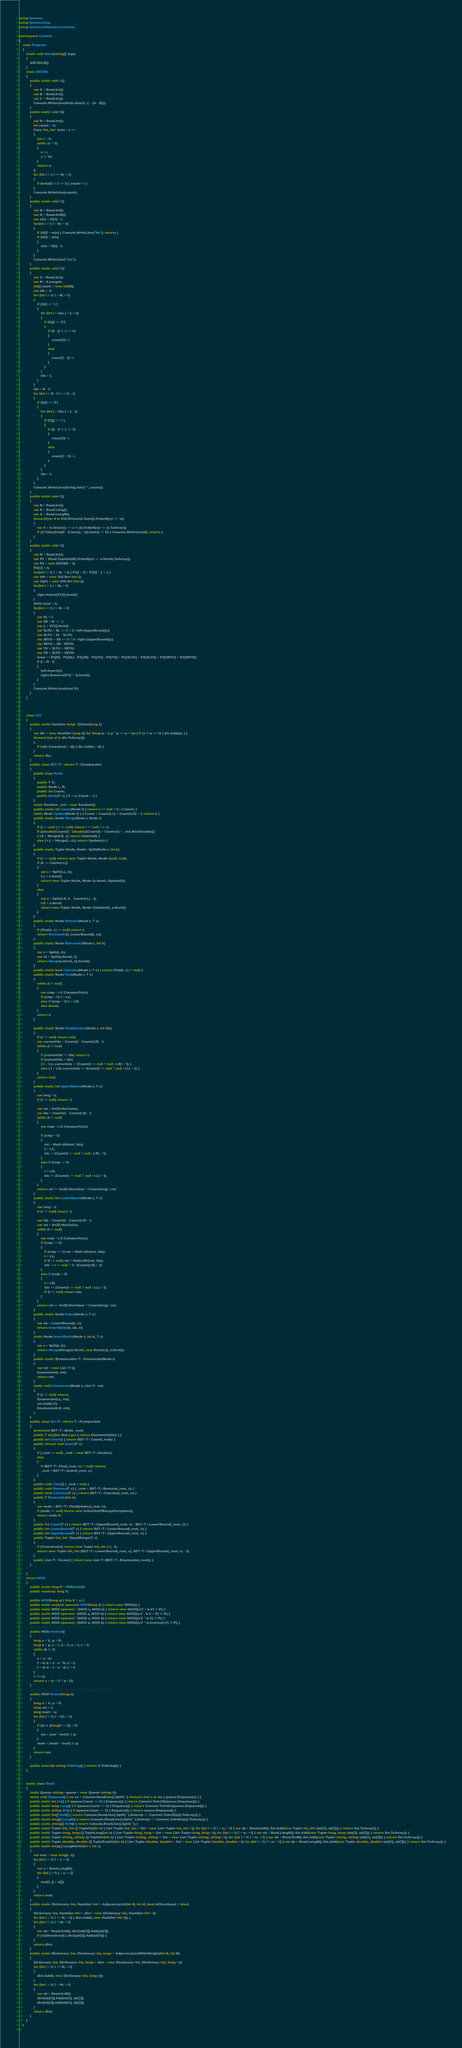<code> <loc_0><loc_0><loc_500><loc_500><_C#_>using System;
using System.Linq;
using System.Collections.Generic;

namespace Contest
{
    class Program
    {
        static void Main(string[] args)
        {
            ABC136.B();
        }
        class ABC136
        {
            public static void A()
            {
                var A = Read.Int();
                var B = Read.Int();
                var C = Read.Int();
                Console.WriteLine(Math.Max(0, C - (A - B)));
            }
            public static void B()
            {
                var N = Read.Int();
                int count = 0;
                Func<int, int> keta = x =>
                {
                    int c = 0;
                    while (x > 0)
                    {
                        c++;
                        x /= 10;
                    }
                    return c;
                };
                for (int i = 1; i <= N; ++i)
                {
                    if (keta(i) % 2 == 1) { count++; }
                }
                Console.WriteLine(count);
            }
            public static void C()
            {
                var N = Read.Int();
                var H = Read.IntN();
                var min = H[0] - 1;
                for(int i = 1; i < N; ++i)
                {
                    if (H[i] < min) { Console.WriteLine("No"); return; }
                    if (H[i] > min)
                    {
                        min = H[i] - 1;
                    }
                }
                Console.WriteLine("Yes");
            }
            public static void D()
            {
                var S = Read.Str();
                var N = S.Length;
                int[] count = new int[N];
                var idx = 0;
                for (int i = 0; i < N; ++i)
                {
                    if (S[i] == 'L')
                    {
                        for (int j = idx; j < i; ++j)
                        {
                            if (S[j] == 'R')
                            {
                                if ((i - j) % 2 == 0)
                                {
                                    count[i]++;
                                }
                                else
                                {
                                    count[i - 1]++;
                                }
                            }
                        }
                        idx = i;
                    }
                }
                idx = N - 1;
                for (int i = N - 1; i >= 0; --i)
                {
                    if (S[i] == 'R')
                    {
                        for (int j = idx; j > i; --j)
                        {
                            if (S[j] == 'L')
                            {
                                if ((j - i) % 2 == 0)
                                {
                                    count[i]++;
                                }
                                else
                                {
                                    count[i + 1]++;
                                }
                            }
                        }
                        idx = i;
                    }
                }
                Console.WriteLine(String.Join(" ", count));
            }
            public static void E()
            {
                var N = Read.Int();
                var K = Read.Long();
                var A = Read.LongN();
                foreach(var d in Util.Divisor(A.Sum()).OrderBy(x => -x))
                {
                    var X = A.Select(x => x % d).OrderBy(x => x).ToArray();
                    if (X.Take((int)(N - X.Sum() / d)).Sum() <= K) { Console.WriteLine(d); return; }
                }
            }
            public static void F()
            {
                var N = Read.Int();
                var XY = Read.TupleInt(N).OrderBy(x => x.Item1).ToArray();
                var P2 = new MOD[N + 1];
                P2[0] = 0;
                for(int i = 0; i < N; ++i) { P2[i + 1] = P2[i] * 2 + 1; }
                var left = new Util.Set<int>();
                var right = new Util.Set<int>();
                for(int i = 1; i < N; ++i)
                {
                    right.Insert(XY[i].Item2);
                }
                MOD total = 0;
                for(int i = 0; i < N; ++i)
                {
                    var XL = i;
                    var XR = N - i - 1;
                    var y = XY[i].Item2;
                    var XLYD = XL == 0 ? 0 : left.UpperBound(y);
                    var XLYU = XL - XLYD;
                    var XRYD = XR == 0 ? 0 : right.UpperBound(y);
                    var XRYU = XR - XRYD;
                    var YU = XLYU + XRYU;
                    var YD = XLYD + XRYD;
                    total += P2[N] - P2[XL] - P2[XR] - P2[YU] - P2[YD] + P2[XLYU] + P2[XLYD] + P2[XRYU] + P2[XRYD];
                    if (i < N - 1)
                    {
                        left.Insert(y);
                        right.Remove(XY[i + 1].Item2);
                    }
                }
                Console.WriteLine(total.V);
            }
        }



        class Util
        {
            public static HashSet<long> Divisor(long x)
            {
                var div = new HashSet<long>(); for (long p = 1; p * p <= x; ++p) { if (x % p == 0) { div.Add(p); } }
                foreach (var d in div.ToArray())
                {
                    if (!div.Contains(x / d)) { div.Add(x / d); }
                }
                return div;
            }
            public class BST<T> where T : IComparable
            {
                public class Node
                {
                    public T V;
                    public Node L, R;
                    public int Count;
                    public Node(T v) { V = v; Count = 1; }
                }
                static Random _rnd = new Random();
                public static int Count(Node t) { return t == null ? 0 : t.Count; }
                static Node Update(Node t) { t.Count = Count(t.L) + Count(t.R) + 1; return t; }
                public static Node Merge(Node l, Node r)
                {
                    if (l == null || r == null) return l == null ? r : l;
                    if ((double)Count(l) / (double)(Count(l) + Count(r)) > _rnd.NextDouble())
                    { l.R = Merge(l.R, r); return Update(l); }
                    else { r.L = Merge(l, r.L); return Update(r); }
                }
                public static Tuple<Node, Node> Split(Node t, int k)
                {
                    if (t == null) return new Tuple<Node, Node>(null, null);
                    if (k <= Count(t.L))
                    {
                        var s = Split(t.L, k);
                        t.L = s.Item2;
                        return new Tuple<Node, Node>(s.Item1, Update(t));
                    }
                    else
                    {
                        var s = Split(t.R, k - Count(t.L) - 1);
                        t.R = s.Item1;
                        return new Tuple<Node, Node>(Update(t), s.Item2);
                    }
                }
                public static Node Remove(Node t, T v)
                {
                    if (Find(t, v) == null) return t;
                    return RemoveAt(t, LowerBound(t, v));
                }
                public static Node RemoveAt(Node t, int k)
                {
                    var s = Split(t, k);
                    var s2 = Split(s.Item2, 1);
                    return Merge(s.Item1, s2.Item2);
                }
                public static bool Contains(Node t, T v) { return Find(t, v) != null; }
                public static Node Find(Node t, T v)
                {
                    while (t != null)
                    {
                        var cmp = t.V.CompareTo(v);
                        if (cmp > 0) t = t.L;
                        else if (cmp < 0) t = t.R;
                        else break;
                    }
                    return t;
                }

                public static Node FindByIndex(Node t, int idx)
                {
                    if (t == null) return null;
                    var currentIdx = Count(t) - Count(t.R) - 1;
                    while (t != null)
                    {
                        if (currentIdx == idx) return t;
                        if (currentIdx > idx)
                        { t = t.L; currentIdx -= (Count(t == null ? null : t.R) + 1); }
                        else { t = t.R; currentIdx += (Count(t == null ? null : t.L) + 1); }
                    }
                    return null;
                }
                public static int UpperBound(Node t, T v)
                {
                    var torg = t;
                    if (t == null) return -1;

                    var ret = Int32.MaxValue;
                    var idx = Count(t) - Count(t.R) - 1;
                    while (t != null)
                    {
                        var cmp = t.V.CompareTo(v);

                        if (cmp > 0)
                        {
                            ret = Math.Min(ret, idx);
                            t = t.L;
                            idx -= (Count(t == null ? null : t.R) + 1);
                        }
                        else if (cmp <= 0)
                        {
                            t = t.R;
                            idx += (Count(t == null ? null : t.L) + 1);
                        }
                    }
                    return ret == Int32.MaxValue ? Count(torg) : ret;
                }
                public static int LowerBound(Node t, T v)
                {
                    var torg = t;
                    if (t == null) return -1;

                    var idx = Count(t) - Count(t.R) - 1;
                    var ret = Int32.MaxValue;
                    while (t != null)
                    {
                        var cmp = t.V.CompareTo(v);
                        if (cmp >= 0)
                        {
                            if (cmp == 0) ret = Math.Min(ret, idx);
                            t = t.L;
                            if (t == null) ret = Math.Min(ret, idx);
                            idx -= t == null ? 0 : (Count(t.R) + 1);
                        }
                        else if (cmp < 0)
                        {
                            t = t.R;
                            idx += (Count(t == null ? null : t.L) + 1);
                            if (t == null) return idx;
                        }
                    }
                    return ret == Int32.MaxValue ? Count(torg) : ret;
                }
                public static Node Insert(Node t, T v)
                {
                    var ub = LowerBound(t, v);
                    return InsertByIdx(t, ub, v);
                }
                static Node InsertByIdx(Node t, int k, T v)
                {
                    var s = Split(t, k);
                    return Merge(Merge(s.Item1, new Node(v)), s.Item2);
                }
                public static IEnumerable<T> Enumerate(Node t)
                {
                    var ret = new List<T>();
                    Enumerate(t, ret);
                    return ret;
                }
                static void Enumerate(Node t, List<T> ret)
                {
                    if (t == null) return;
                    Enumerate(t.L, ret);
                    ret.Add(t.V);
                    Enumerate(t.R, ret);
                }
            }
            public class Set<T> where T : IComparable
            {
                protected BST<T>.Node _root;
                public T this[int idx] { get { return ElementAt(idx); } }
                public int Count() { return BST<T>.Count(_root); }
                public virtual void Insert(T v)
                {
                    if (_root == null) _root = new BST<T>.Node(v);
                    else
                    {
                        if (BST<T>.Find(_root, v) != null) return;
                        _root = BST<T>.Insert(_root, v);
                    }
                }
                public void Clear() { _root = null; }
                public void Remove(T v) { _root = BST<T>.Remove(_root, v); }
                public bool Contains(T v) { return BST<T>.Contains(_root, v); }
                public T ElementAt(int k)
                {
                    var node = BST<T>.FindByIndex(_root, k);
                    if (node == null) throw new IndexOutOfRangeException();
                    return node.V;
                }
                public int Count(T v) { return BST<T>.UpperBound(_root, v) - BST<T>.LowerBound(_root, v); }
                public int LowerBound(T v) { return BST<T>.LowerBound(_root, v); }
                public int UpperBound(T v) { return BST<T>.UpperBound(_root, v); }
                public Tuple<int, int> EqualRange(T v)
                {
                    if (!Contains(v)) return new Tuple<int, int>(-1, -1);
                    return new Tuple<int, int>(BST<T>.LowerBound(_root, v), BST<T>.UpperBound(_root, v) - 1);
                }
                public List<T> ToList() { return new List<T>(BST<T>.Enumerate(_root)); }
            }

        }
        struct MOD
        {
            public static long P = 998244353;
            public readonly long V;

            public MOD(long a) { this.V = a; }
            public static implicit operator MOD(long a) { return new MOD(a); }
            public static MOD operator +(MOD a, MOD b) { return new MOD((a.V + b.V) % P); }
            public static MOD operator -(MOD a, MOD b) { return new MOD((a.V - b.V + P) % P); }
            public static MOD operator *(MOD a, MOD b) { return new MOD((a.V * b.V) % P); }
            public static MOD operator /(MOD a, MOD b) { return new MOD((a.V * b.Inverse().V) % P); }
            //public MOD Inverse() { return Util.Inverse(V, P); }
            public MOD Inverse()
            {
                long a = V, p = P;
                long b = p, c = 1, d = 0, e = 0, f = 0;
                while (b != 0)
                {
                    e = a / b;
                    f = b; b = a - e * b; a = f;
                    f = d; d = c - e * d; c = f;
                }
                c %= p;
                return c + (c < 0 ? p : 0);
            }
            //public MOD Power(long n) { return Util.Power(V, n, P); }
            public MOD Power(long n)
            {
                long a = V, p = P;
                long res = 1;
                long mult = a;
                for (int i = 0; i < 40; ++i)
                {
                    if ((n & ((long)1 << i)) > 0)
                    {
                        res = (res * mult) % p;
                    }
                    mult = (mult * mult) % p;
                }
                return res;
            }

            public override string ToString() { return V.ToString(); }
        }


        static class Read
        {
            static Queue<string> queue = new Queue<string>();
            static void Enqueue() { var ss = Console.ReadLine().Split(' '); foreach (var s in ss) { queue.Enqueue(s); } }
            public static int Int() { if (queue.Count == 0) { Enqueue(); } return Convert.ToInt32(queue.Dequeue()); }
            public static long Long() { if (queue.Count == 0) { Enqueue(); } return Convert.ToInt64(queue.Dequeue()); }
            public static string Str() { if (queue.Count == 0) { Enqueue(); } return queue.Dequeue(); }
            public static int[] IntN() { return Console.ReadLine().Split(' ').Select(s => Convert.ToInt32(s)).ToArray(); }
            public static long[] LongN() { return Console.ReadLine().Split(' ').Select(s => Convert.ToInt64(s)).ToArray(); }
            public static string[] StrN() { return Console.ReadLine().Split(' '); }
            public static Tuple<int, int>[] TupleInt(int n) { List<Tuple<int, int>> list = new List<Tuple<int, int>>(); for (int i = 0; i < n; ++i) { var ab = Read.IntN(); list.Add(new Tuple<int, int>(ab[0], ab[1])); } return list.ToArray(); }
            public static Tuple<long, long>[] TupleLong(int n) { List<Tuple<long, long>> list = new List<Tuple<long, long>>(); for (int i = 0; i < n; ++i) { var ab = Read.LongN(); list.Add(new Tuple<long, long>(ab[0], ab[1])); } return list.ToArray(); }
            public static Tuple<string, string>[] TupleStr(int n) { List<Tuple<string, string>> list = new List<Tuple<string, string>>(); for (int i = 0; i < n; ++i) { var ab = Read.StrN(); list.Add(new Tuple<string, string>(ab[0], ab[1])); } return list.ToArray(); }
            public static Tuple<double, double>[] TupleDouble(int n) { List<Tuple<double, double>> list = new List<Tuple<double, double>>(); for (int i = 0; i < n; ++i) { var ab = Read.LongN(); list.Add(new Tuple<double, double>(ab[0], ab[1])); } return list.ToArray(); }
            public static long[,] LongMatrix(int r, int c)
            {
                var mat = new long[r, c];
                for (int i = 0; i < r; ++i)
                {
                    var x = Read.LongN();
                    for (int j = 0; j < c; ++j)
                    {
                        mat[i, j] = x[j];
                    }
                }
                return mat;
            }
            public static Dictionary<int, HashSet<int>> AdjacencyList(int N, int M, bool isDirectional = false)
            {
                Dictionary<int, HashSet<int>> dict = new Dictionary<int, HashSet<int>>();
                for (int i = 0; i <= N; ++i) { dict.Add(i, new HashSet<int>()); }
                for (int i = 0; i < M; ++i)
                {
                    var ab = Read.IntN(); dict[ab[0]].Add(ab[1]);
                    if (!isDirectional) { dict[ab[1]].Add(ab[0]); }
                }
                return dict;
            }
            public static Dictionary<int, Dictionary<int, long>> AdjacencyListWithWeight(int N, int M)
            {
                Dictionary<int, Dictionary<int, long>> dict = new Dictionary<int, Dictionary<int, long>>();
                for (int i = 0; i <= N; ++i)
                {
                    dict.Add(i, new Dictionary<int, long>());
                }
                for (int i = 0; i < M; ++i)
                {
                    var ab = Read.IntN();
                    dict[ab[0]].Add(ab[1], ab[2]);
                    dict[ab[1]].Add(ab[0], ab[2]);
                }
                return dict;
            }
        }
    }
}
</code> 